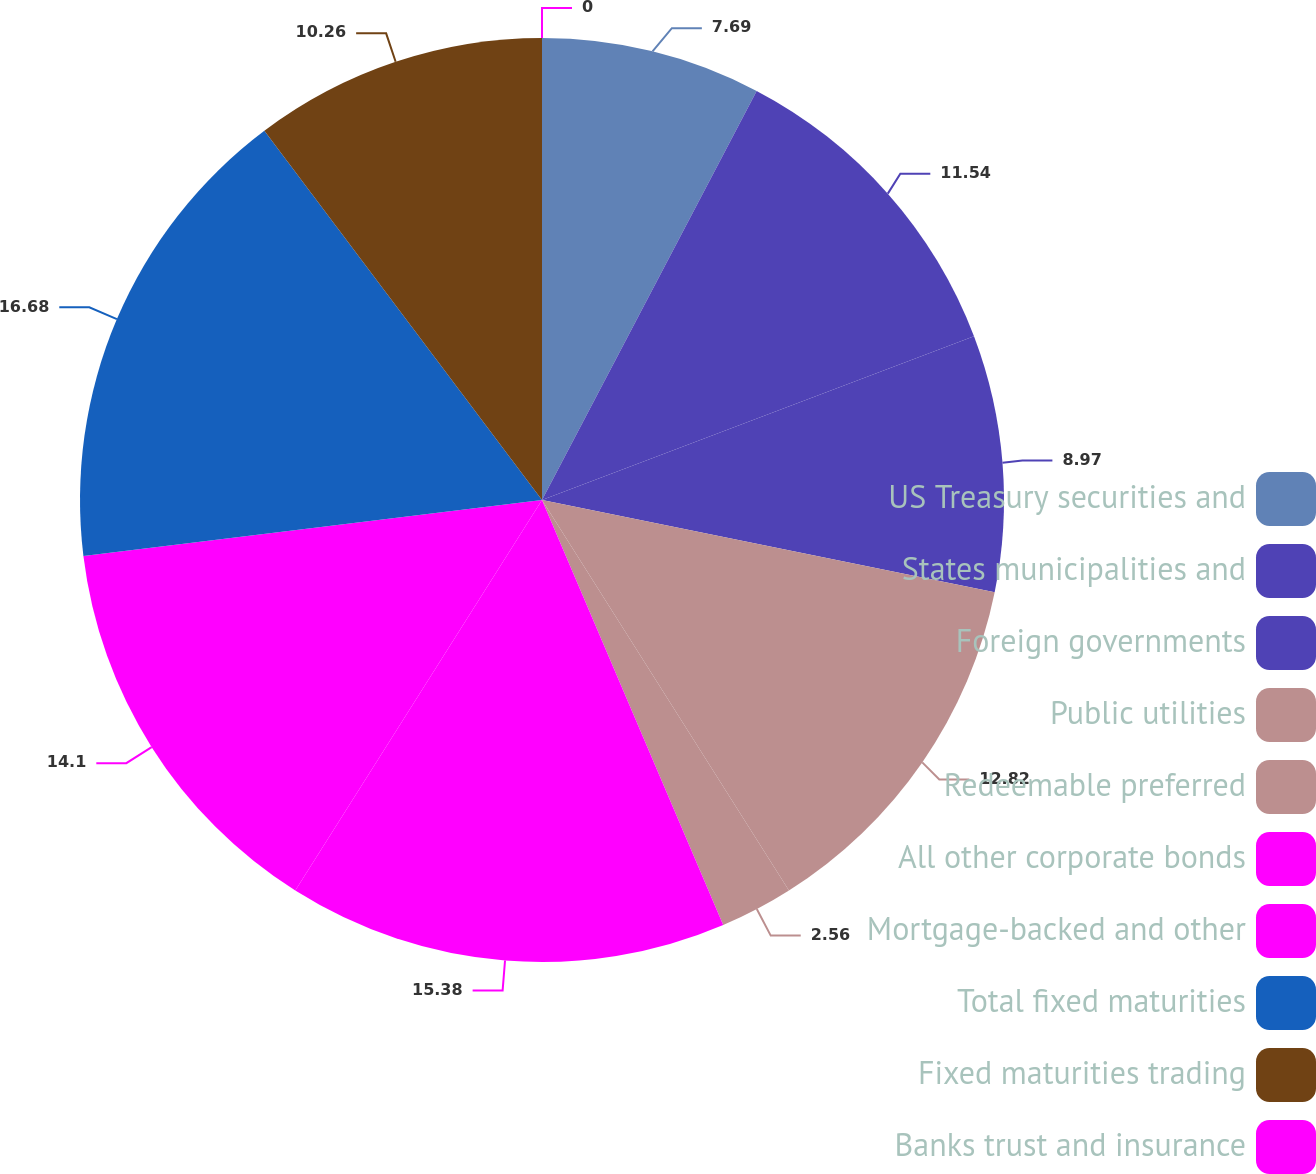Convert chart to OTSL. <chart><loc_0><loc_0><loc_500><loc_500><pie_chart><fcel>US Treasury securities and<fcel>States municipalities and<fcel>Foreign governments<fcel>Public utilities<fcel>Redeemable preferred<fcel>All other corporate bonds<fcel>Mortgage-backed and other<fcel>Total fixed maturities<fcel>Fixed maturities trading<fcel>Banks trust and insurance<nl><fcel>7.69%<fcel>11.54%<fcel>8.97%<fcel>12.82%<fcel>2.56%<fcel>15.38%<fcel>14.1%<fcel>16.67%<fcel>10.26%<fcel>0.0%<nl></chart> 